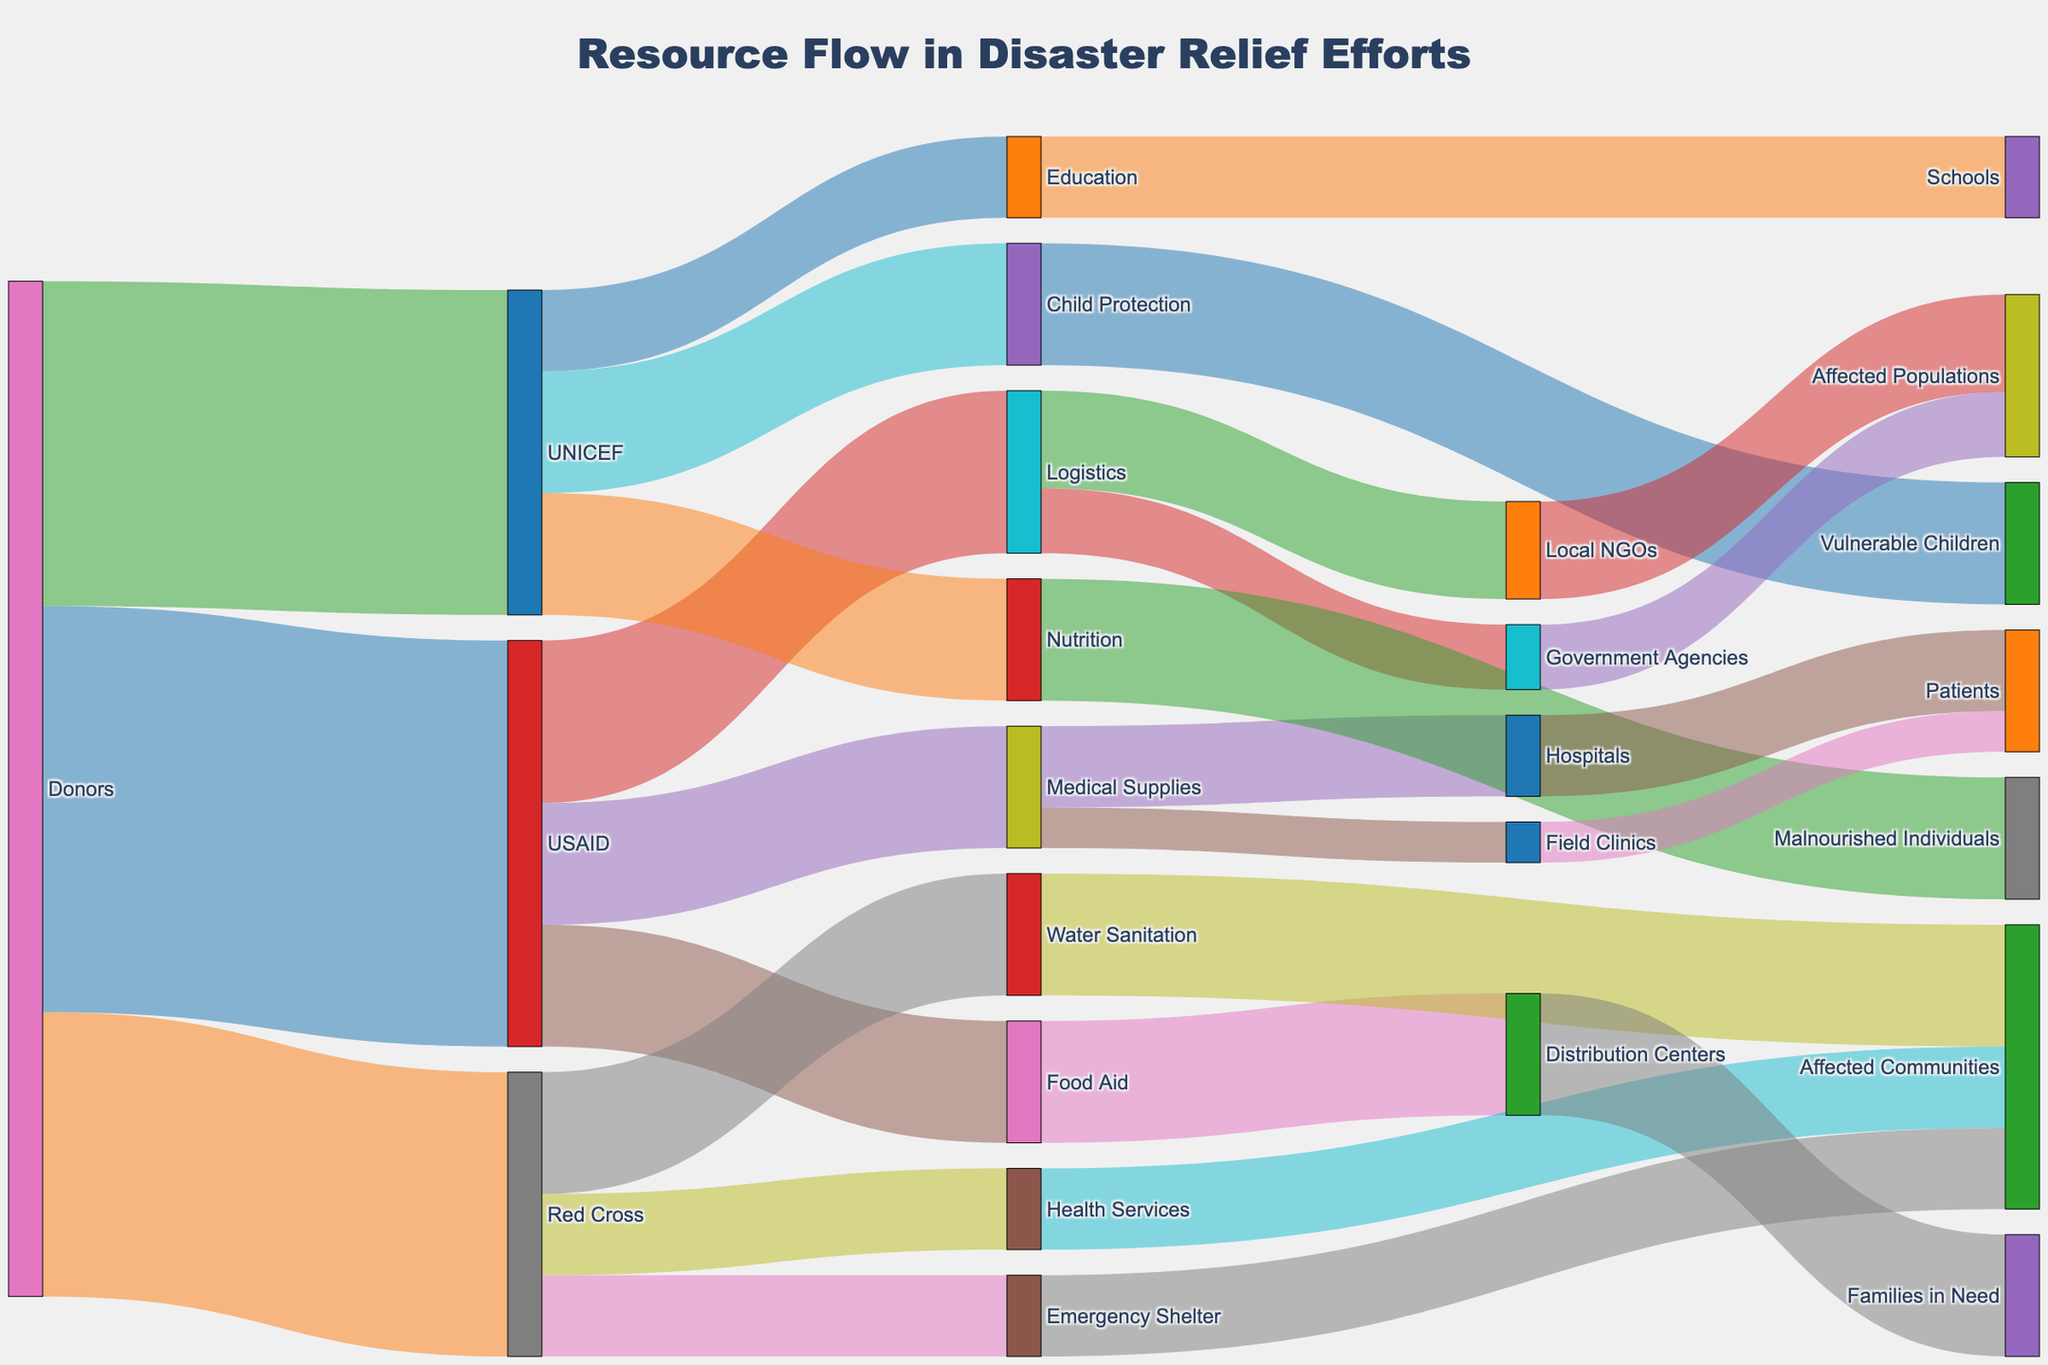What is the total amount of resources provided by USAID? To find the total resources provided by USAID, sum the values directed from USAID: Logistics ($2,000,000), Medical Supplies ($1,500,000), and Food Aid ($1,500,000). The total is $2,000,000 + $1,500,000 + $1,500,000 = $5,000,000.
Answer: $5,000,000 Which donor provided the most resources? Compare the values provided by each donor. Donors provided $5,000,000 to USAID, $3,500,000 to Red Cross, and $4,000,000 to UNICEF. USAID received the most resources: $5,000,000.
Answer: USAID How much did Red Cross allocate to Health Services? From the diagram, Red Cross allocated $1,000,000 to Health Services.
Answer: $1,000,000 What is the total amount of resources allocated to affected communities by Red Cross? Sum the values directed from Red Cross to affected communities through different channels: Emergency Shelter ($1,000,000), Water Sanitation ($1,500,000), and Health Services ($1,000,000). The total is $1,000,000 + $1,500,000 + $1,000,000 = $3,500,000.
Answer: $3,500,000 What are the three main categories funded by UNICEF and their corresponding values? UNICEF funded Child Protection ($1,500,000), Education ($1,000,000), and Nutrition ($1,500,000).
Answer: Child Protection ($1,500,000), Education ($1,000,000), Nutrition ($1,500,000) Which category received the least amount of resources from donors? Check the smallest individual value in the chart under each category funded by donors. Education received $1,000,000, which is the smallest value.
Answer: Education How much total funding flows through distribution centers? Distribution centers only receive funding under Food Aid, specifically $1,500,000.
Answer: $1,500,000 What is the combined amount allocated to Logistics and Food Aid by USAID, and how does it compare to their total funds? Find the sum of amounts directed to Logistics and Food Aid by USAID: Logistics ($2,000,000) + Food Aid ($1,500,000) = $3,500,000. Then compare it with USAID's total funds: (3,500,000 / 5,000,000) * 100%. The result is 70%.
Answer: $3,500,000; 70% of total How much in total did affected populations receive from all sources? Sum all values directed to affected populations from various sources: Local NGOs ($1,200,000) + Government Agencies ($800,000) + Distribution Centers ($1,500,000) + Affected Communities (through emergency shelter, water sanitation, and health services, $3,500,000) = $7,000,000.
Answer: $7,000,000 